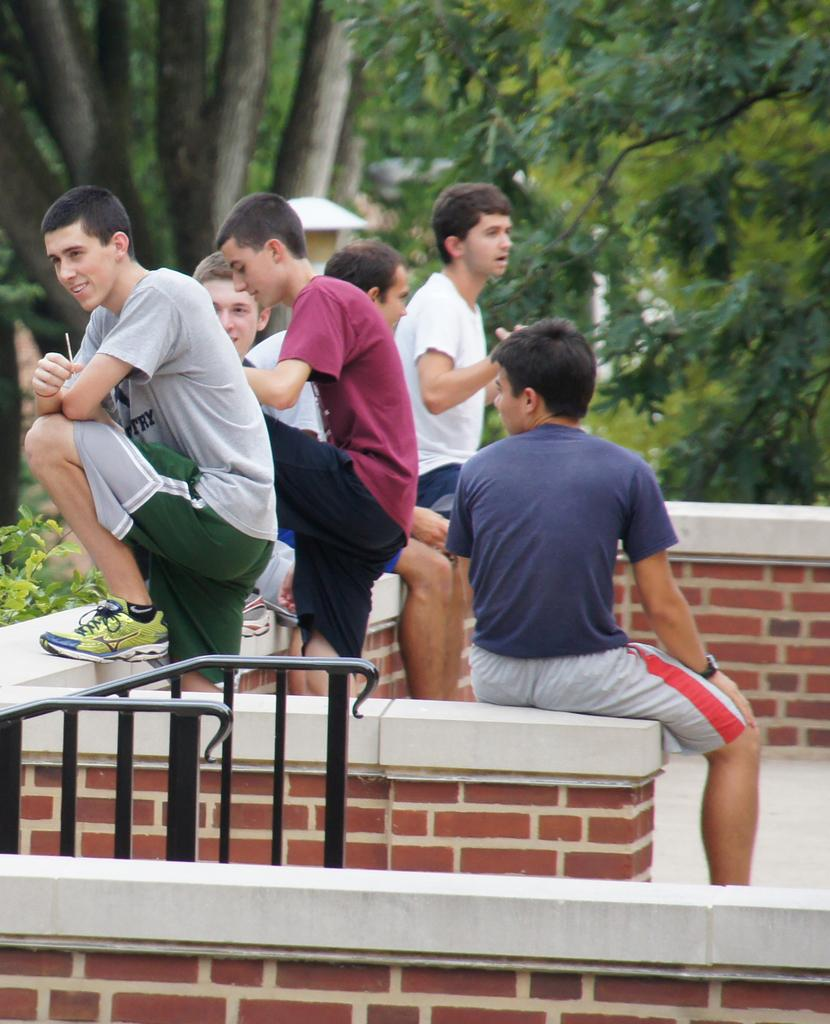What type of people can be seen in the image? There are men in the image. What are the positions of the men in the image? Some of the men are standing, while others are seated. What can be seen in the background of the image? There are trees visible in the image. How many clocks are visible on the men's wrists in the image? There are no clocks visible on the men's wrists in the image. What type of muscle is being exercised by the men in the image? There is no indication of any exercise or muscle activity in the image; the men are simply standing or seated. 